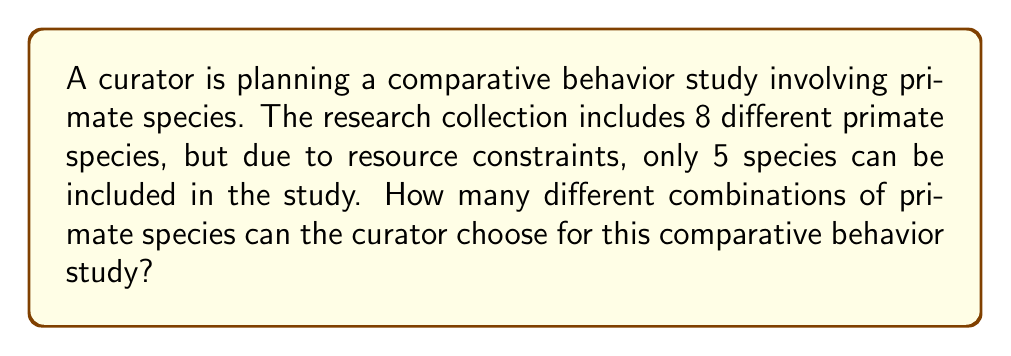Give your solution to this math problem. To solve this problem, we need to use the combination formula. We are selecting 5 species out of 8 available species, where the order doesn't matter (combinations, not permutations).

The formula for combinations is:

$$ C(n,r) = \binom{n}{r} = \frac{n!}{r!(n-r)!} $$

Where:
$n$ = total number of items to choose from (8 primate species)
$r$ = number of items being chosen (5 species for the study)

Let's substitute these values:

$$ C(8,5) = \binom{8}{5} = \frac{8!}{5!(8-5)!} = \frac{8!}{5!3!} $$

Now, let's calculate:

$$ \frac{8 \cdot 7 \cdot 6 \cdot 5!}{5! \cdot 3 \cdot 2 \cdot 1} $$

The 5! cancels out in the numerator and denominator:

$$ \frac{8 \cdot 7 \cdot 6}{3 \cdot 2 \cdot 1} = \frac{336}{6} = 56 $$

Therefore, the curator can choose 56 different combinations of 5 primate species for the comparative behavior study.
Answer: 56 combinations 